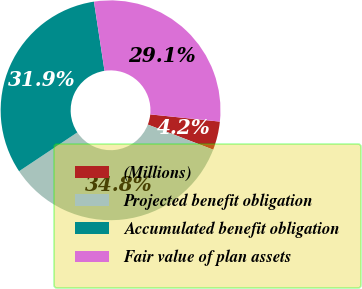Convert chart. <chart><loc_0><loc_0><loc_500><loc_500><pie_chart><fcel>(Millions)<fcel>Projected benefit obligation<fcel>Accumulated benefit obligation<fcel>Fair value of plan assets<nl><fcel>4.19%<fcel>34.82%<fcel>31.94%<fcel>29.06%<nl></chart> 